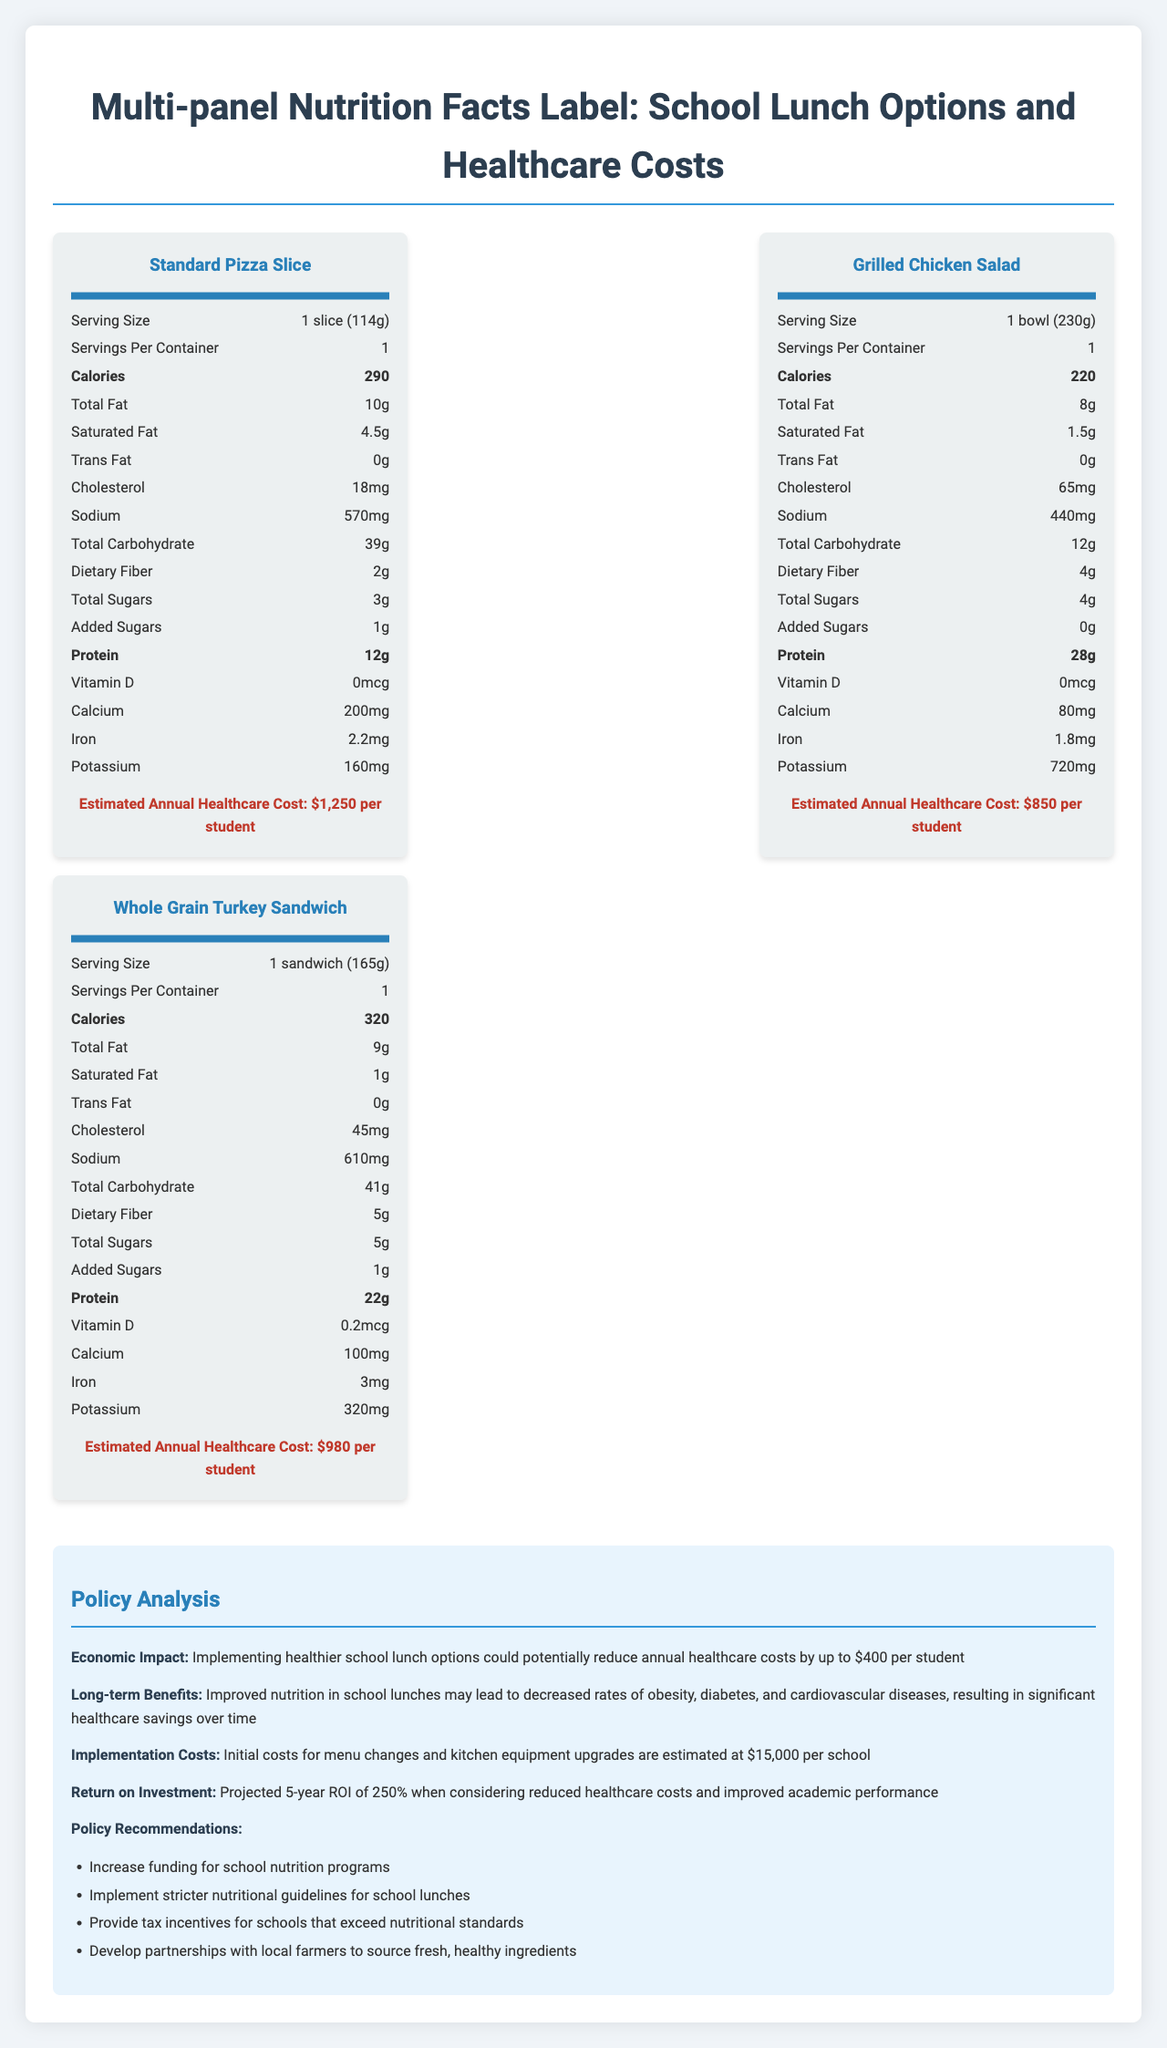what is the serving size of the Standard Pizza Slice? The serving size is provided in the nutrition panel for the Standard Pizza Slice.
Answer: 1 slice (114g) how many calories are in a Grilled Chicken Salad? The nutrition panel for the Grilled Chicken Salad lists the calorie content as 220.
Answer: 220 calories what is the estimated annual healthcare cost for a student eating a Whole Grain Turkey Sandwich? The healthcare cost is provided in the nutrition panel for the Whole Grain Turkey Sandwich.
Answer: $980 per student how much dietary fiber does the Standard Pizza Slice contain? The amount of dietary fiber is listed in the nutritional information in the Standard Pizza Slice panel.
Answer: 2g which lunch option has the highest protein content? The Grilled Chicken Salad has 28g of protein, which is higher than the other options.
Answer: Grilled Chicken Salad how much sodium is in the Whole Grain Turkey Sandwich? The sodium content for the Whole Grain Turkey Sandwich is provided in its nutritional information.
Answer: 610mg what are the potential long-term benefits of implementing healthier school lunch options, according to the policy analysis? The policy analysis section lists these as long-term benefits.
Answer: Decreased rates of obesity, diabetes, and cardiovascular diseases, resulting in significant healthcare savings over time which lunch option has the least amount of calories? A. Standard Pizza Slice B. Grilled Chicken Salad C. Whole Grain Turkey Sandwich The Grilled Chicken Salad has 220 calories, the lowest among the three options.
Answer: B. Grilled Chicken Salad how many grams of saturated fat are in the Standard Pizza Slice? A. 1g B. 1.5g C. 4.5g D. 5g The nutrition panel for the Standard Pizza Slice indicates that it contains 4.5g of saturated fat.
Answer: C. 4.5g what is the school lunch option with the highest cholesterol content? A. Standard Pizza Slice B. Grilled Chicken Salad C. Whole Grain Turkey Sandwich The Grilled Chicken Salad has 65mg of cholesterol, the highest among the options.
Answer: B. Grilled Chicken Salad should stricter nutritional guidelines for school lunches be implemented, according to the policy recommendations? One of the policy recommendations includes implementing stricter nutritional guidelines for school lunches.
Answer: Yes describe the main idea of the document. The document combines nutritional information with estimated healthcare costs for different lunch options and offers policy recommendations to improve school lunch programs.
Answer: The document provides a multi-panel nutrition facts label comparing the nutritional values and estimated annual healthcare costs of three school lunch options – Standard Pizza Slice, Grilled Chicken Salad, and Whole Grain Turkey Sandwich. It also includes policy analysis discussing economic impacts, long-term benefits, implementation costs, and policy recommendations for healthier school lunch programs. what are the added sugars in the Grilled Chicken Salad? Added sugars for the Grilled Chicken Salad are listed as 0g in the nutrition panel.
Answer: 0g which lunch option contains the most potassium? The Grilled Chicken Salad has 720mg of potassium, the highest among the options.
Answer: Grilled Chicken Salad what is the implementation cost for new menu changes and kitchen equipment upgrades per school mentioned in the policy analysis? The policy analysis lists the implementation costs for menu changes and kitchen equipment upgrades as $15,000 per school.
Answer: $15,000 how does the policy analysis evaluate the return on investment (ROI) over five years? The policy analysis section mentions a projected 5-year ROI of 250% by considering reduced healthcare costs and improved academic performance.
Answer: Projected 5-year ROI of 250% what specific partnership does the policy analysis recommend developing? One of the policy recommendations is to develop partnerships with local farmers to source fresh, healthy ingredients.
Answer: Partnership with local farmers to source fresh, healthy ingredients 